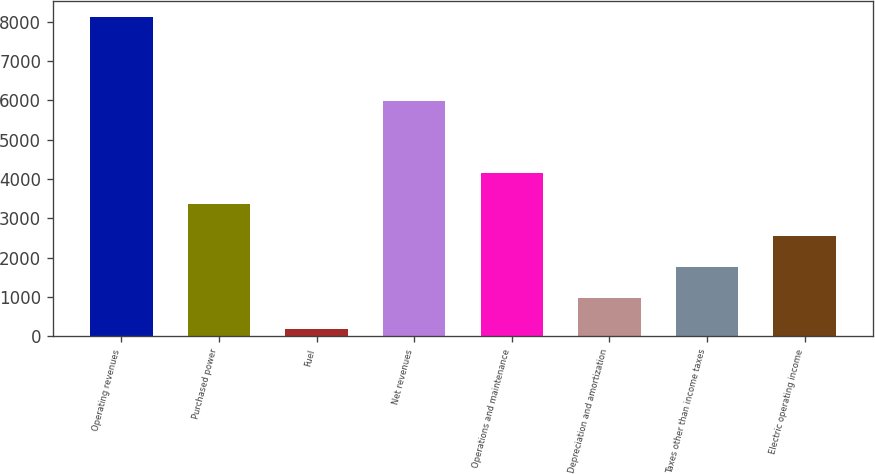Convert chart to OTSL. <chart><loc_0><loc_0><loc_500><loc_500><bar_chart><fcel>Operating revenues<fcel>Purchased power<fcel>Fuel<fcel>Net revenues<fcel>Operations and maintenance<fcel>Depreciation and amortization<fcel>Taxes other than income taxes<fcel>Electric operating income<nl><fcel>8131<fcel>3356.8<fcel>174<fcel>5983<fcel>4152.5<fcel>969.7<fcel>1765.4<fcel>2561.1<nl></chart> 